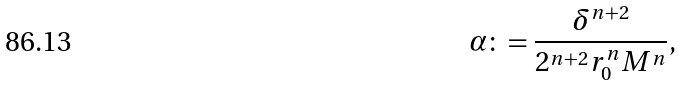<formula> <loc_0><loc_0><loc_500><loc_500>\alpha \colon = \frac { \delta ^ { n + 2 } } { 2 ^ { n + 2 } r _ { 0 } ^ { n } M ^ { n } } ,</formula> 